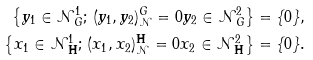<formula> <loc_0><loc_0><loc_500><loc_500>\left \{ y _ { 1 } \in \mathcal { N } ^ { 1 } _ { G } ; \, ( y _ { 1 } , y _ { 2 } ) ^ { G } _ { \mathcal { N } } = 0 y _ { 2 } \in \mathcal { N } ^ { 2 } _ { G } \right \} & = \{ 0 \} , \\ \left \{ x _ { 1 } \in \mathcal { N } ^ { 1 } _ { \mathbf H } ; \, ( x _ { 1 } , x _ { 2 } ) ^ { \mathbf H } _ { \mathcal { N } } = 0 x _ { 2 } \in \mathcal { N } ^ { 2 } _ { \mathbf H } \right \} & = \{ 0 \} .</formula> 